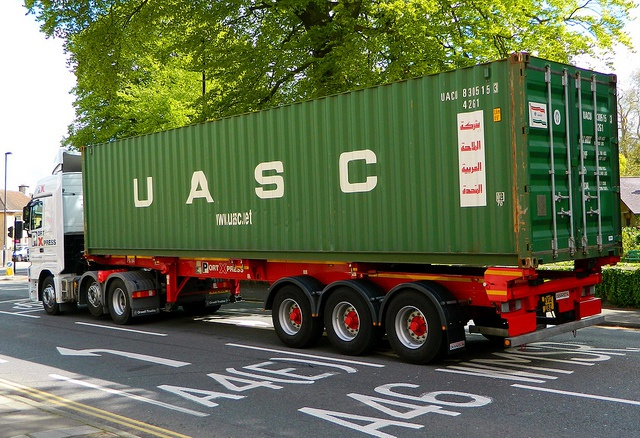Describe the objects in this image and their specific colors. I can see truck in white, darkgreen, and black tones, car in white, gray, darkgray, and black tones, traffic light in white, black, navy, gray, and olive tones, and traffic light in white, black, and purple tones in this image. 